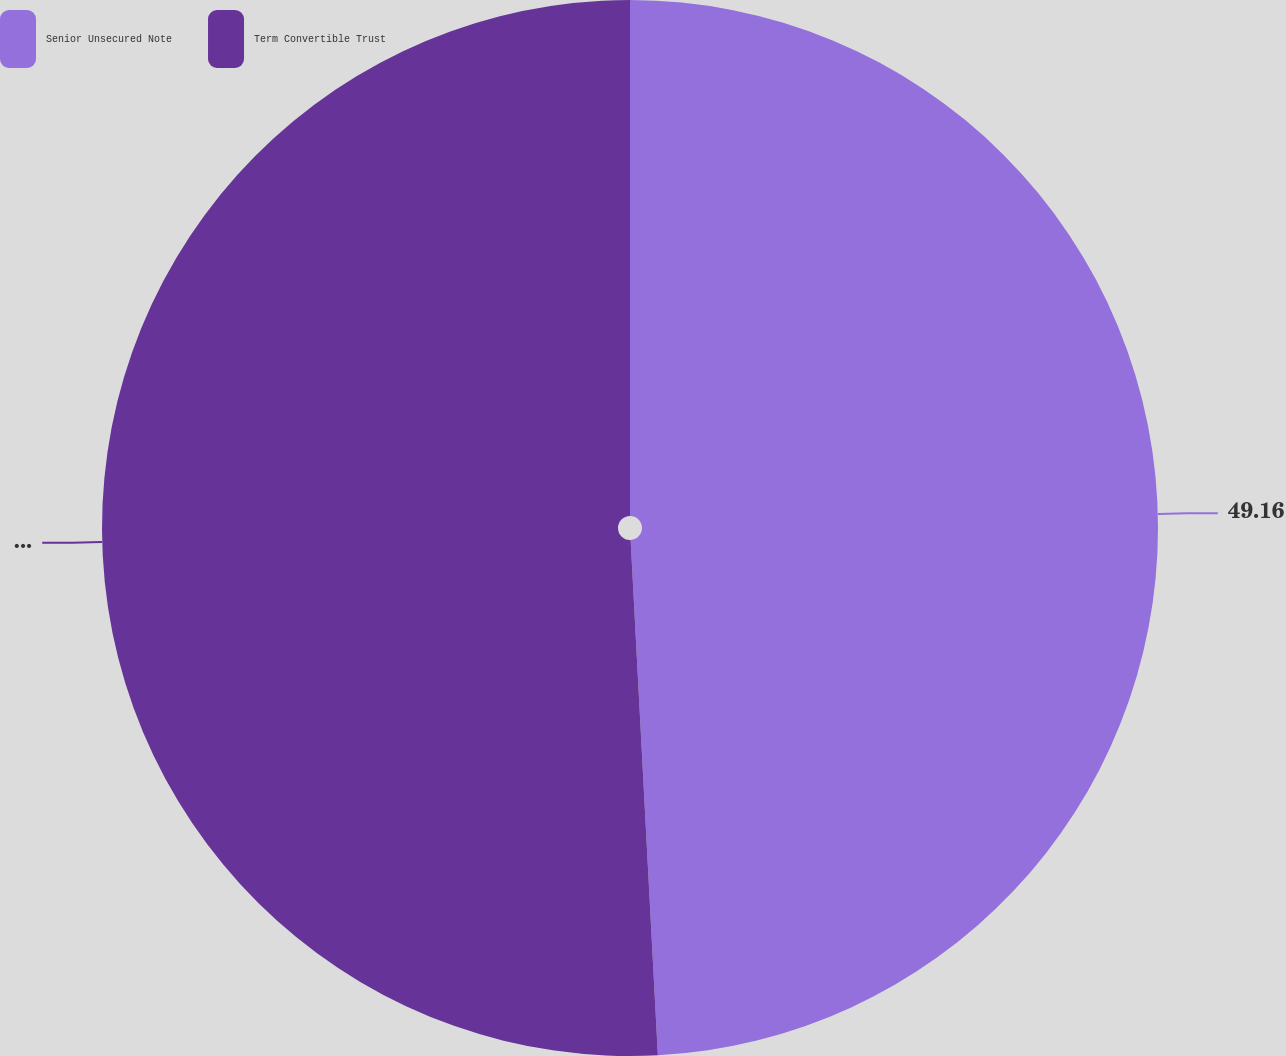Convert chart. <chart><loc_0><loc_0><loc_500><loc_500><pie_chart><fcel>Senior Unsecured Note<fcel>Term Convertible Trust<nl><fcel>49.16%<fcel>50.84%<nl></chart> 